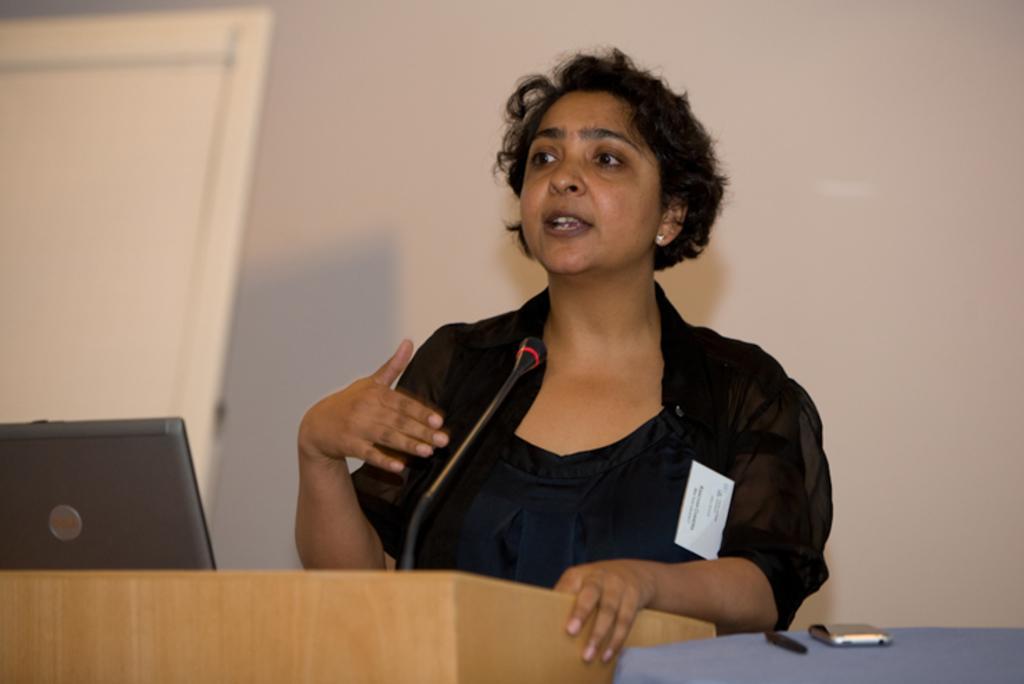Describe this image in one or two sentences. In this image we can see a woman standing in front of a mike and she is talking. Here we can see a podium, laptop, pen, and a mobile. In the background we can see wall and a door. 